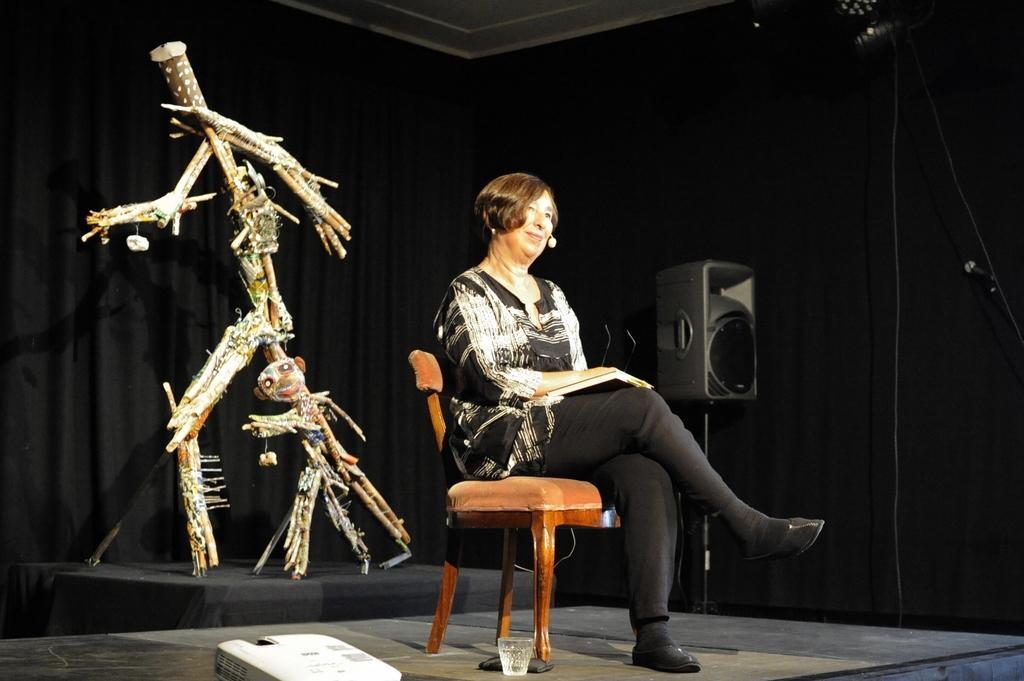Could you give a brief overview of what you see in this image? This image is taken indoors. At the bottom of the image there is a floor. There is a light and there is a glass with water on the floor. In the background there is a speaker box. At the top of the image there is a ceiling. In the middle of the image a woman is sitting on the chair. On the left side of the image there are two scarecrows on the dais. 